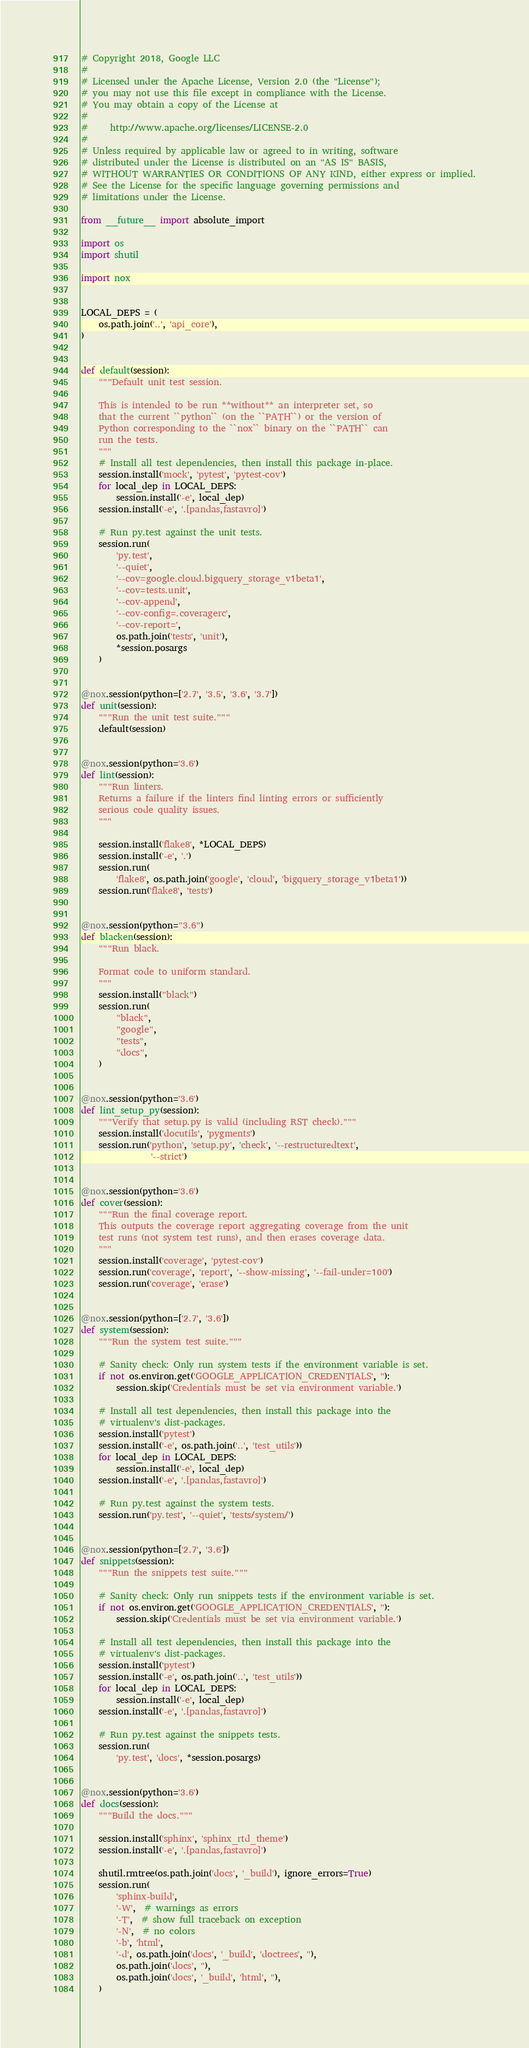<code> <loc_0><loc_0><loc_500><loc_500><_Python_># Copyright 2018, Google LLC
#
# Licensed under the Apache License, Version 2.0 (the "License");
# you may not use this file except in compliance with the License.
# You may obtain a copy of the License at
#
#     http://www.apache.org/licenses/LICENSE-2.0
#
# Unless required by applicable law or agreed to in writing, software
# distributed under the License is distributed on an "AS IS" BASIS,
# WITHOUT WARRANTIES OR CONDITIONS OF ANY KIND, either express or implied.
# See the License for the specific language governing permissions and
# limitations under the License.

from __future__ import absolute_import

import os
import shutil

import nox


LOCAL_DEPS = (
    os.path.join('..', 'api_core'),
)


def default(session):
    """Default unit test session.

    This is intended to be run **without** an interpreter set, so
    that the current ``python`` (on the ``PATH``) or the version of
    Python corresponding to the ``nox`` binary on the ``PATH`` can
    run the tests.
    """
    # Install all test dependencies, then install this package in-place.
    session.install('mock', 'pytest', 'pytest-cov')
    for local_dep in LOCAL_DEPS:
        session.install('-e', local_dep)
    session.install('-e', '.[pandas,fastavro]')

    # Run py.test against the unit tests.
    session.run(
        'py.test',
        '--quiet',
        '--cov=google.cloud.bigquery_storage_v1beta1',
        '--cov=tests.unit',
        '--cov-append',
        '--cov-config=.coveragerc',
        '--cov-report=',
        os.path.join('tests', 'unit'),
        *session.posargs
    )


@nox.session(python=['2.7', '3.5', '3.6', '3.7'])
def unit(session):
    """Run the unit test suite."""
    default(session)


@nox.session(python='3.6')
def lint(session):
    """Run linters.
    Returns a failure if the linters find linting errors or sufficiently
    serious code quality issues.
    """

    session.install('flake8', *LOCAL_DEPS)
    session.install('-e', '.')
    session.run(
        'flake8', os.path.join('google', 'cloud', 'bigquery_storage_v1beta1'))
    session.run('flake8', 'tests')


@nox.session(python="3.6")
def blacken(session):
    """Run black.

    Format code to uniform standard.
    """
    session.install("black")
    session.run(
        "black",
        "google",
        "tests",
        "docs",
    )


@nox.session(python='3.6')
def lint_setup_py(session):
    """Verify that setup.py is valid (including RST check)."""
    session.install('docutils', 'pygments')
    session.run('python', 'setup.py', 'check', '--restructuredtext',
                '--strict')


@nox.session(python='3.6')
def cover(session):
    """Run the final coverage report.
    This outputs the coverage report aggregating coverage from the unit
    test runs (not system test runs), and then erases coverage data.
    """
    session.install('coverage', 'pytest-cov')
    session.run('coverage', 'report', '--show-missing', '--fail-under=100')
    session.run('coverage', 'erase')


@nox.session(python=['2.7', '3.6'])
def system(session):
    """Run the system test suite."""

    # Sanity check: Only run system tests if the environment variable is set.
    if not os.environ.get('GOOGLE_APPLICATION_CREDENTIALS', ''):
        session.skip('Credentials must be set via environment variable.')

    # Install all test dependencies, then install this package into the
    # virtualenv's dist-packages.
    session.install('pytest')
    session.install('-e', os.path.join('..', 'test_utils'))
    for local_dep in LOCAL_DEPS:
        session.install('-e', local_dep)
    session.install('-e', '.[pandas,fastavro]')

    # Run py.test against the system tests.
    session.run('py.test', '--quiet', 'tests/system/')


@nox.session(python=['2.7', '3.6'])
def snippets(session):
    """Run the snippets test suite."""

    # Sanity check: Only run snippets tests if the environment variable is set.
    if not os.environ.get('GOOGLE_APPLICATION_CREDENTIALS', ''):
        session.skip('Credentials must be set via environment variable.')

    # Install all test dependencies, then install this package into the
    # virtualenv's dist-packages.
    session.install('pytest')
    session.install('-e', os.path.join('..', 'test_utils'))
    for local_dep in LOCAL_DEPS:
        session.install('-e', local_dep)
    session.install('-e', '.[pandas,fastavro]')

    # Run py.test against the snippets tests.
    session.run(
        'py.test', 'docs', *session.posargs)


@nox.session(python='3.6')
def docs(session):
    """Build the docs."""

    session.install('sphinx', 'sphinx_rtd_theme')
    session.install('-e', '.[pandas,fastavro]')

    shutil.rmtree(os.path.join('docs', '_build'), ignore_errors=True)
    session.run(
        'sphinx-build',
        '-W',  # warnings as errors
        '-T',  # show full traceback on exception
        '-N',  # no colors
        '-b', 'html',
        '-d', os.path.join('docs', '_build', 'doctrees', ''),
        os.path.join('docs', ''),
        os.path.join('docs', '_build', 'html', ''),
    )
</code> 